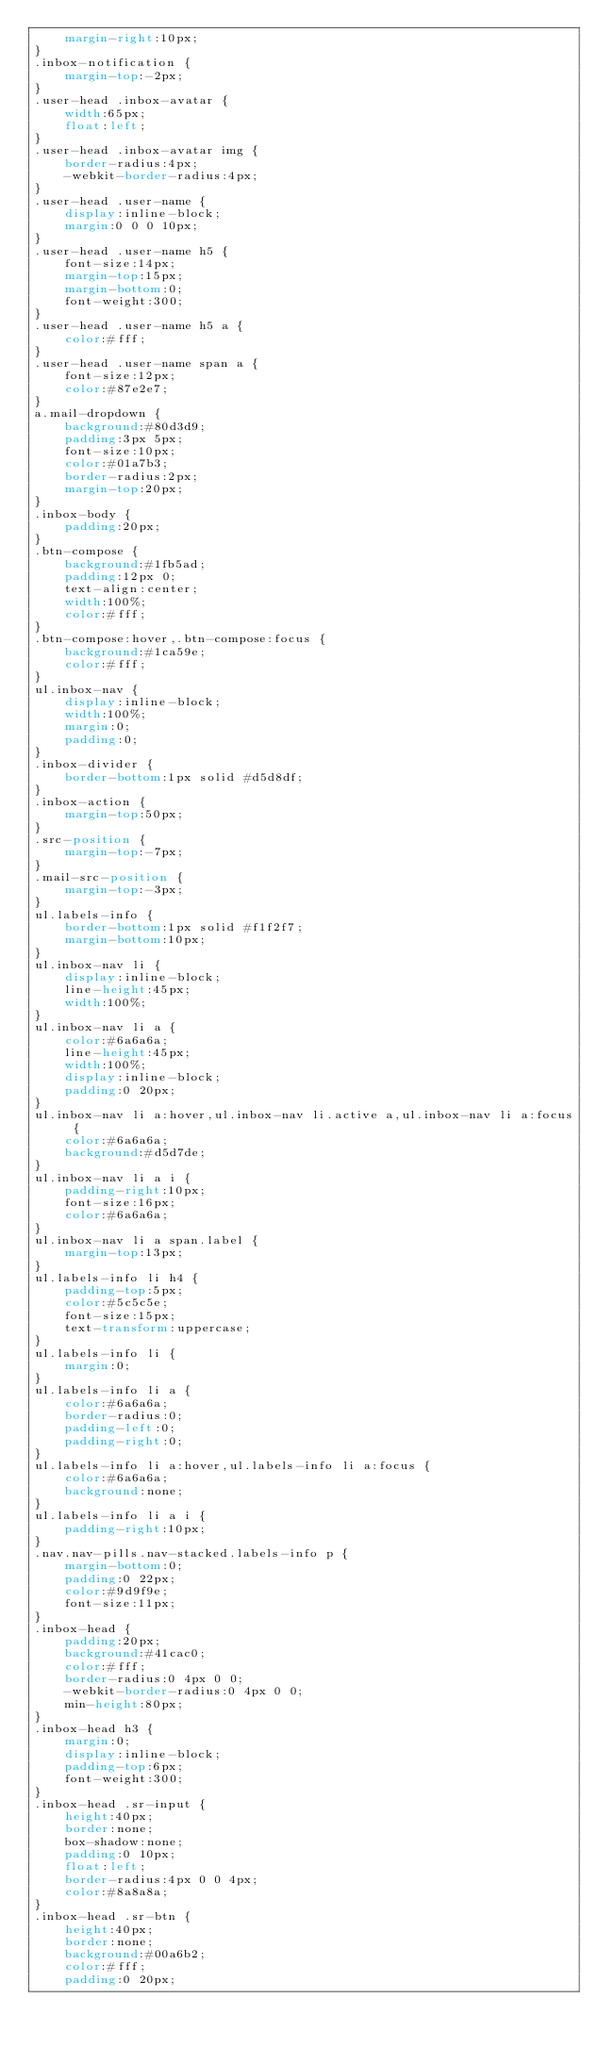<code> <loc_0><loc_0><loc_500><loc_500><_CSS_>    margin-right:10px;
}
.inbox-notification {
    margin-top:-2px;
}
.user-head .inbox-avatar {
    width:65px;
    float:left;
}
.user-head .inbox-avatar img {
    border-radius:4px;
    -webkit-border-radius:4px;
}
.user-head .user-name {
    display:inline-block;
    margin:0 0 0 10px;
}
.user-head .user-name h5 {
    font-size:14px;
    margin-top:15px;
    margin-bottom:0;
    font-weight:300;
}
.user-head .user-name h5 a {
    color:#fff;
}
.user-head .user-name span a {
    font-size:12px;
    color:#87e2e7;
}
a.mail-dropdown {
    background:#80d3d9;
    padding:3px 5px;
    font-size:10px;
    color:#01a7b3;
    border-radius:2px;
    margin-top:20px;
}
.inbox-body {
    padding:20px;
}
.btn-compose {
    background:#1fb5ad;
    padding:12px 0;
    text-align:center;
    width:100%;
    color:#fff;
}
.btn-compose:hover,.btn-compose:focus {
    background:#1ca59e;
    color:#fff;
}
ul.inbox-nav {
    display:inline-block;
    width:100%;
    margin:0;
    padding:0;
}
.inbox-divider {
    border-bottom:1px solid #d5d8df;
}
.inbox-action {
    margin-top:50px;
}
.src-position {
    margin-top:-7px;
}
.mail-src-position {
    margin-top:-3px;
}
ul.labels-info {
    border-bottom:1px solid #f1f2f7;
    margin-bottom:10px;
}
ul.inbox-nav li {
    display:inline-block;
    line-height:45px;
    width:100%;
}
ul.inbox-nav li a {
    color:#6a6a6a;
    line-height:45px;
    width:100%;
    display:inline-block;
    padding:0 20px;
}
ul.inbox-nav li a:hover,ul.inbox-nav li.active a,ul.inbox-nav li a:focus {
    color:#6a6a6a;
    background:#d5d7de;
}
ul.inbox-nav li a i {
    padding-right:10px;
    font-size:16px;
    color:#6a6a6a;
}
ul.inbox-nav li a span.label {
    margin-top:13px;
}
ul.labels-info li h4 {
    padding-top:5px;
    color:#5c5c5e;
    font-size:15px;
    text-transform:uppercase;
}
ul.labels-info li {
    margin:0;
}
ul.labels-info li a {
    color:#6a6a6a;
    border-radius:0;
    padding-left:0;
    padding-right:0;
}
ul.labels-info li a:hover,ul.labels-info li a:focus {
    color:#6a6a6a;
    background:none;
}
ul.labels-info li a i {
    padding-right:10px;
}
.nav.nav-pills.nav-stacked.labels-info p {
    margin-bottom:0;
    padding:0 22px;
    color:#9d9f9e;
    font-size:11px;
}
.inbox-head {
    padding:20px;
    background:#41cac0;
    color:#fff;
    border-radius:0 4px 0 0;
    -webkit-border-radius:0 4px 0 0;
    min-height:80px;
}
.inbox-head h3 {
    margin:0;
    display:inline-block;
    padding-top:6px;
    font-weight:300;
}
.inbox-head .sr-input {
    height:40px;
    border:none;
    box-shadow:none;
    padding:0 10px;
    float:left;
    border-radius:4px 0 0 4px;
    color:#8a8a8a;
}
.inbox-head .sr-btn {
    height:40px;
    border:none;
    background:#00a6b2;
    color:#fff;
    padding:0 20px;</code> 